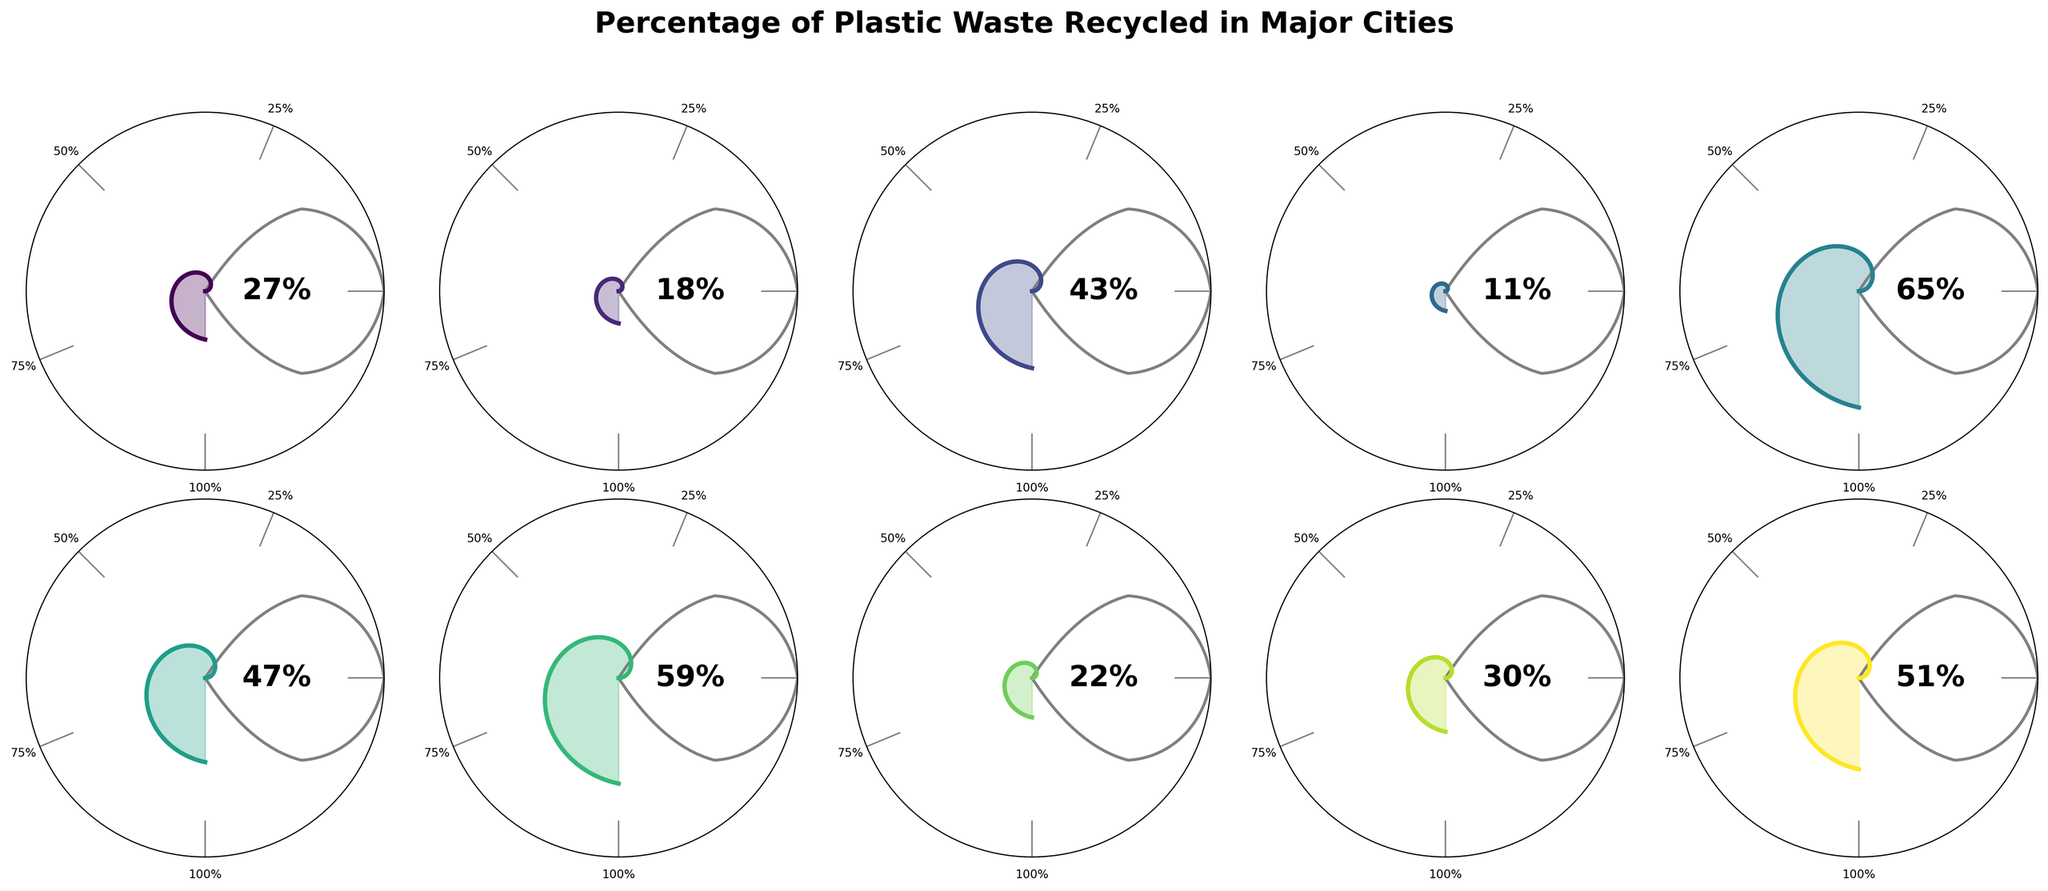what is the percentage of plastic waste recycled in San Francisco? Looking at the Gauge Chart for San Francisco, the percentage of plastic waste recycled is displayed inside the chart.
Answer: 65% Which city has the lowest percentage of plastic waste recycled? By comparing the percentages marked on each of the gauge charts, Mumbai has the lowest percentage of plastic waste recycled at 11%.
Answer: Mumbai How many cities have a plastic recycling percentage greater than 50%? From the gauge charts, the cities with percentages greater than 50% are San Francisco (65%), Amsterdam (51%), and Singapore (59%). So, there are 3 cities.
Answer: 3 What is the average percentage of plastic waste recycled across all the cities? Adding all the percentages from the gauge charts (27 + 18 + 43 + 11 + 65 + 47 + 59 + 22 + 30 + 51) gives a total of 373%. Dividing by the number of cities (10) gives the average. 373 / 10 = 37.3%
Answer: 37.3% Is there any city with exactly 25% of plastic waste recycled? Checking each of the gauge charts, no city has exactly 25% of plastic waste recycled.
Answer: No Which city has the second highest percentage of plastic waste recycled? The highest percentage is San Francisco with 65%. The next highest percentage is Singapore with 59%.
Answer: Singapore Does London recycle more plastic waste than Tokyo? Comparing the percentages for London (43%) and Tokyo (27%), London has a higher percentage of plastic waste recycled.
Answer: Yes What is the median percentage of plastic waste recycled in these cities? The sorted percentages are: 11, 18, 22, 27, 30, 43, 47, 51, 59, 65. The median is the average of the 5th and 6th values: (30 + 43) / 2 = 36.5%
Answer: 36.5% Which city ranks fifth in terms of percentage of plastic waste recycled? Sorting the cities by their percentages: 11 (Mumbai), 18 (New York City), 22 (Shanghai), 27 (Tokyo), 30 (Sydney), 43 (London), 47 (Berlin), 51 (Amsterdam), 59 (Singapore), 65 (San Francisco). Sydney ranks fifth.
Answer: Sydney Are there more cities recycling less than 30% or more than 30% of plastic waste? Cities recycling less than 30%: New York City (18%), Mumbai (11%), Shanghai (22%), Tokyo (27%). Total: 4 cities. Cities recycling more than 30%: Sydney (30%), London (43%), Berlin (47%), Amsterdam (51%), Singapore (59%), San Francisco (65%). Total: 6 cities.
Answer: More cities recycle more than 30% 